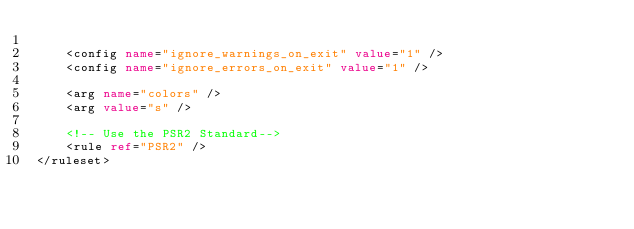Convert code to text. <code><loc_0><loc_0><loc_500><loc_500><_XML_>
    <config name="ignore_warnings_on_exit" value="1" />
    <config name="ignore_errors_on_exit" value="1" />

    <arg name="colors" />
    <arg value="s" />

    <!-- Use the PSR2 Standard-->
    <rule ref="PSR2" />
</ruleset>
</code> 